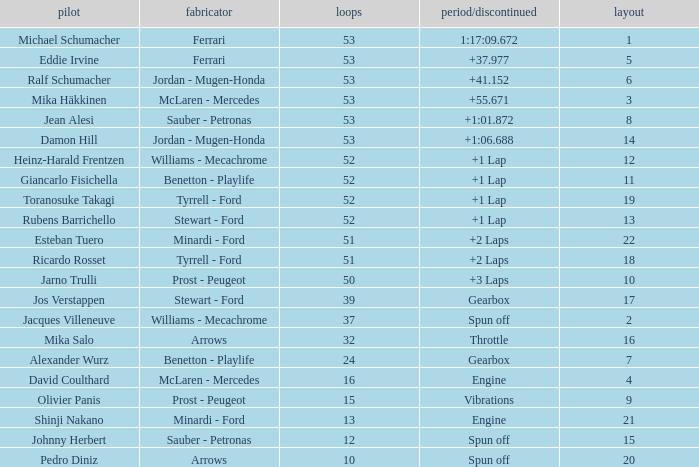What is the high lap total for pedro diniz? 10.0. 